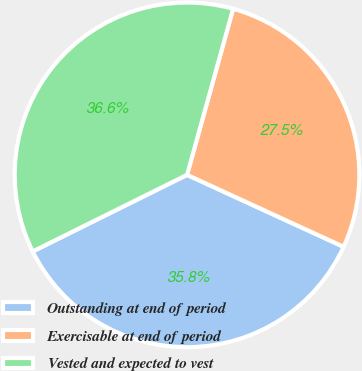Convert chart. <chart><loc_0><loc_0><loc_500><loc_500><pie_chart><fcel>Outstanding at end of period<fcel>Exercisable at end of period<fcel>Vested and expected to vest<nl><fcel>35.81%<fcel>27.55%<fcel>36.64%<nl></chart> 